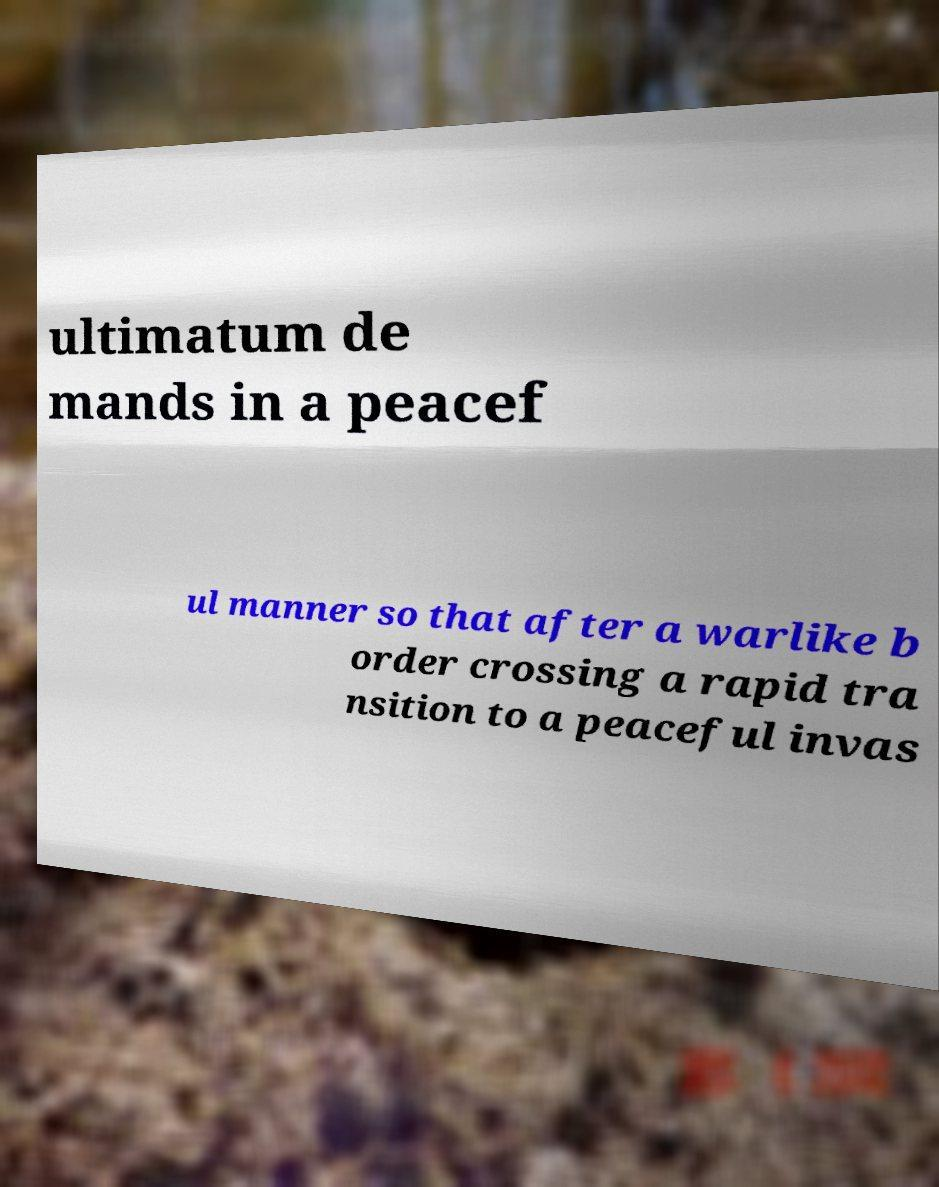Could you assist in decoding the text presented in this image and type it out clearly? ultimatum de mands in a peacef ul manner so that after a warlike b order crossing a rapid tra nsition to a peaceful invas 